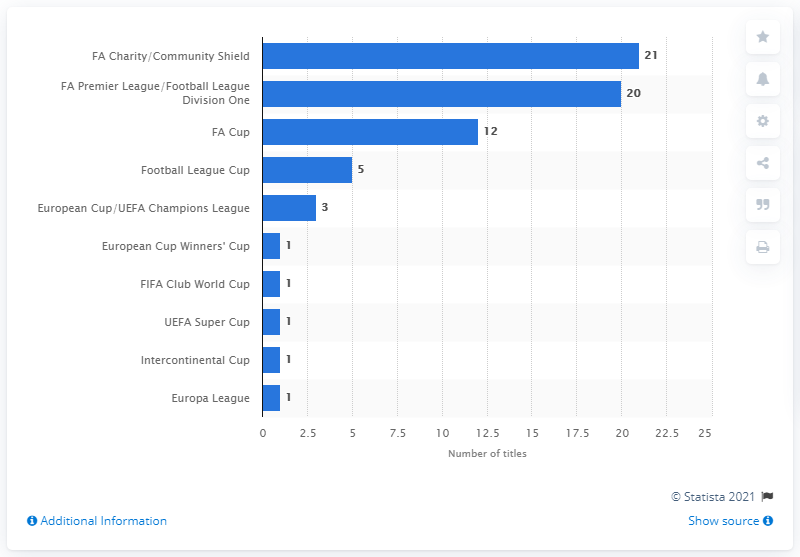Draw attention to some important aspects in this diagram. Since 1889, Manchester United has won the English top flight a total of 20 times. Manchester United have won the FA Cup 12 times. 